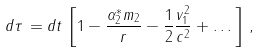Convert formula to latex. <formula><loc_0><loc_0><loc_500><loc_500>d \tau \, = d t \, \left [ 1 - \frac { \alpha _ { 2 } ^ { * } m _ { 2 } } { r } - \frac { 1 } { 2 } \frac { v _ { 1 } ^ { 2 } } { c ^ { 2 } } + \dots \, \right ] \, ,</formula> 